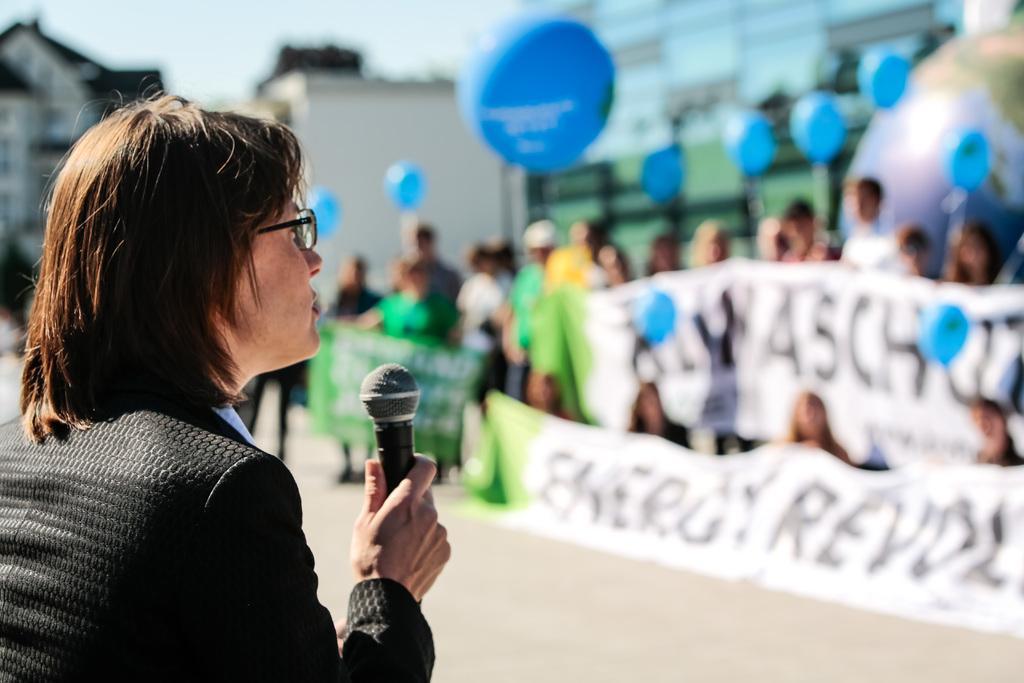Describe this image in one or two sentences. This woman wore suit, holding mic and wore spectacles. The background is blur and we can able to see persons are holding banners and balloons and we can able to see buildings. 